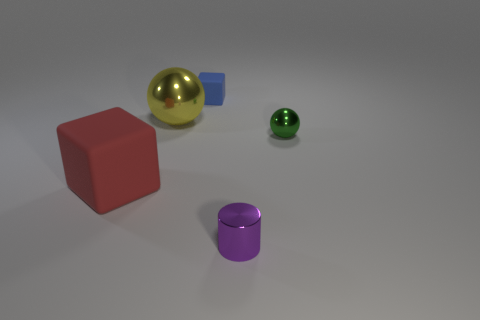Are there any cubes of the same color as the cylinder?
Your response must be concise. No. What number of other things are made of the same material as the tiny green object?
Your answer should be compact. 2. How many small things are either purple cylinders or green spheres?
Provide a succinct answer. 2. Are there an equal number of tiny rubber blocks in front of the red matte block and shiny things?
Offer a terse response. No. There is a cube that is behind the green thing; are there any red rubber blocks that are behind it?
Your answer should be compact. No. What number of other things are there of the same color as the cylinder?
Offer a very short reply. 0. What is the color of the shiny cylinder?
Your answer should be compact. Purple. There is a metal thing that is on the right side of the tiny rubber block and behind the purple shiny cylinder; how big is it?
Your answer should be very brief. Small. How many things are spheres that are on the right side of the purple metal cylinder or metallic spheres?
Your answer should be very brief. 2. There is another thing that is the same material as the large red thing; what shape is it?
Keep it short and to the point. Cube. 